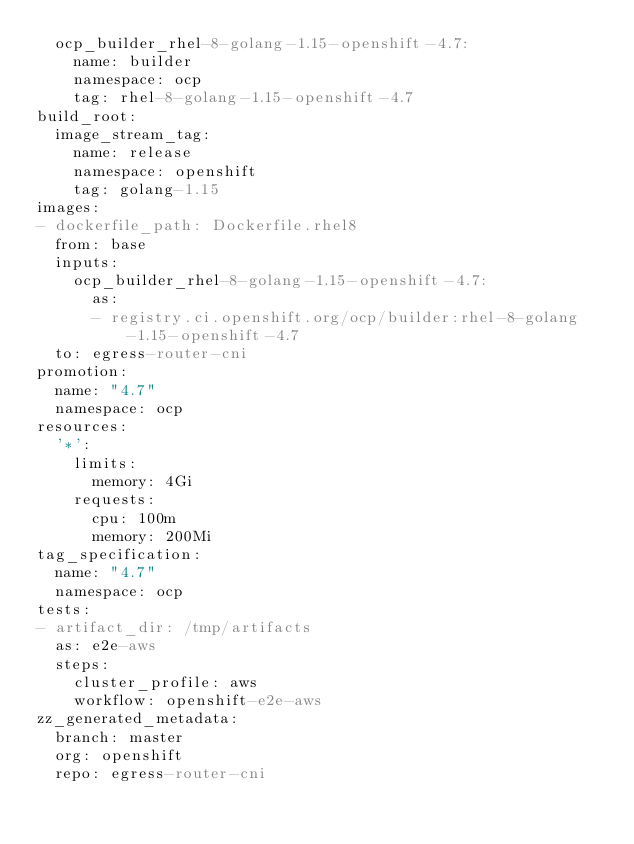Convert code to text. <code><loc_0><loc_0><loc_500><loc_500><_YAML_>  ocp_builder_rhel-8-golang-1.15-openshift-4.7:
    name: builder
    namespace: ocp
    tag: rhel-8-golang-1.15-openshift-4.7
build_root:
  image_stream_tag:
    name: release
    namespace: openshift
    tag: golang-1.15
images:
- dockerfile_path: Dockerfile.rhel8
  from: base
  inputs:
    ocp_builder_rhel-8-golang-1.15-openshift-4.7:
      as:
      - registry.ci.openshift.org/ocp/builder:rhel-8-golang-1.15-openshift-4.7
  to: egress-router-cni
promotion:
  name: "4.7"
  namespace: ocp
resources:
  '*':
    limits:
      memory: 4Gi
    requests:
      cpu: 100m
      memory: 200Mi
tag_specification:
  name: "4.7"
  namespace: ocp
tests:
- artifact_dir: /tmp/artifacts
  as: e2e-aws
  steps:
    cluster_profile: aws
    workflow: openshift-e2e-aws
zz_generated_metadata:
  branch: master
  org: openshift
  repo: egress-router-cni
</code> 